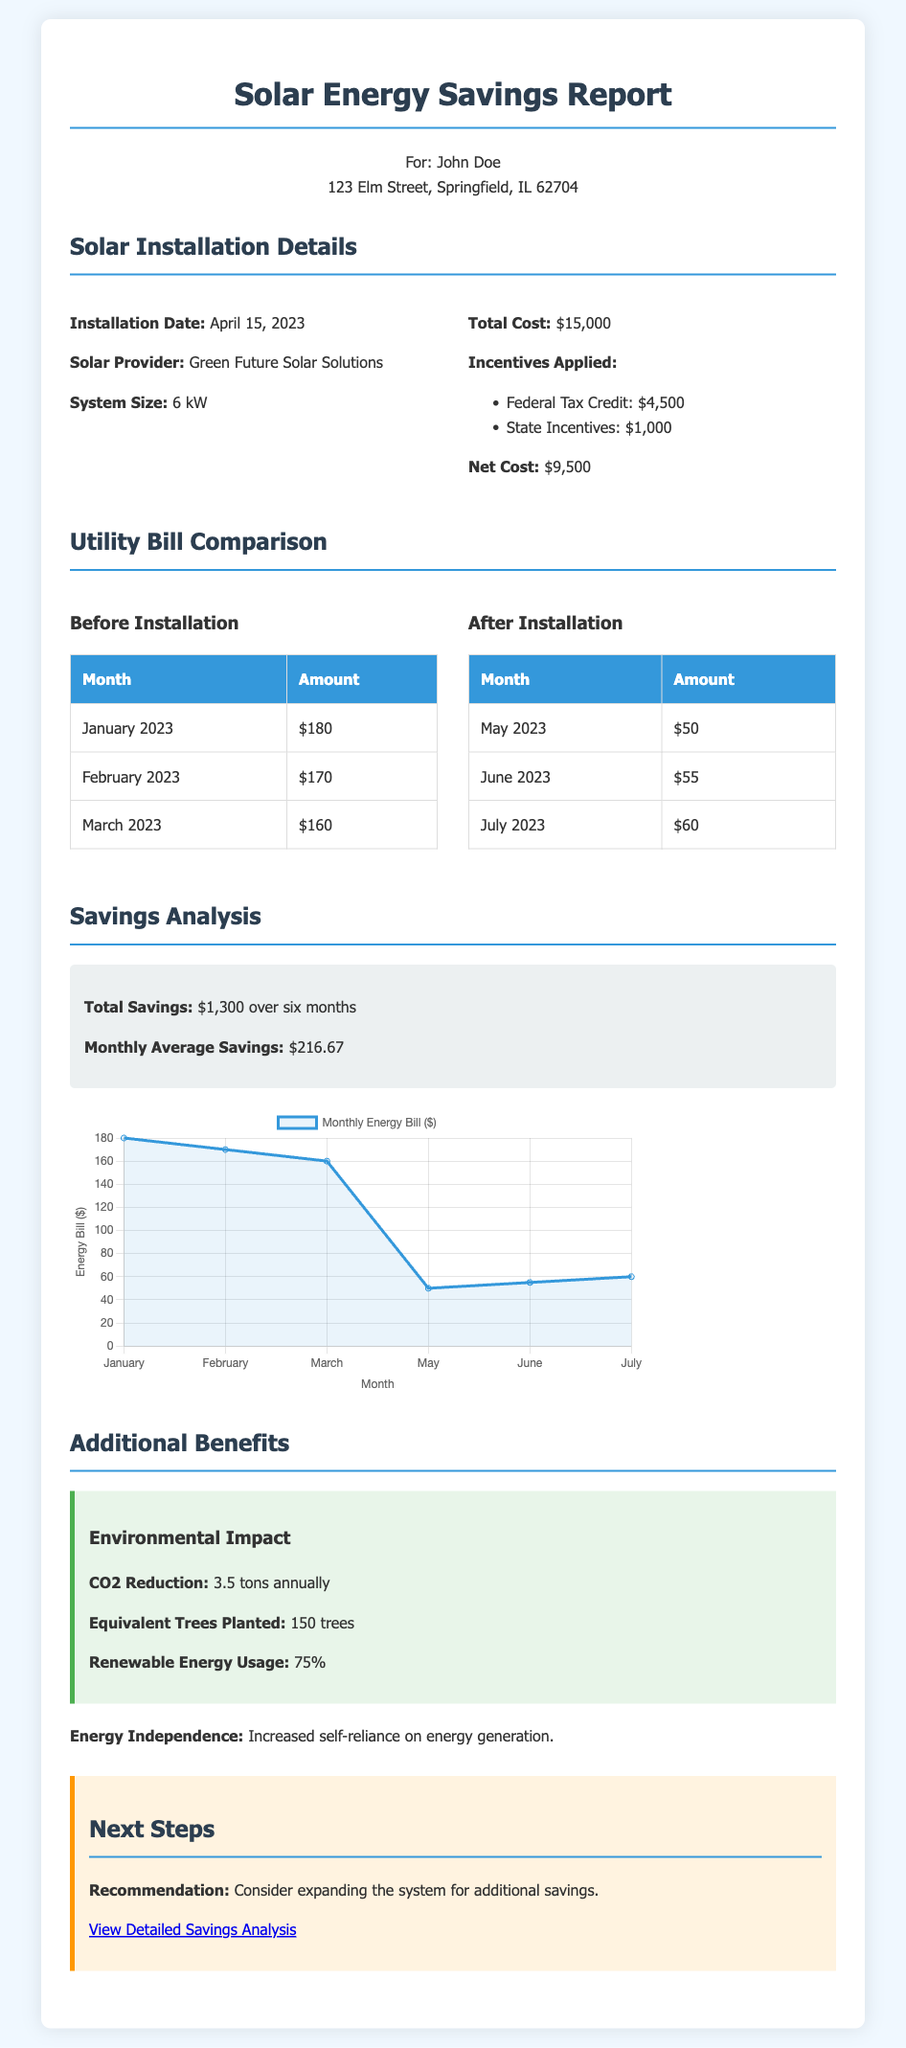what is the installation date? The installation date is stated in the section titled "Solar Installation Details."
Answer: April 15, 2023 what is the total cost of the solar installation? The total cost is mentioned in the Solar Installation Details section.
Answer: $15,000 how much was saved in total over six months? The total savings are specifically highlighted in the Savings Analysis section.
Answer: $1,300 what were the utility bills in January 2023? The bill amount for January 2023 is listed in the Utility Bill Comparison section.
Answer: $180 what is the monthly average savings? The monthly average savings are calculated and mentioned in the Savings Analysis section.
Answer: $216.67 how much CO2 reduction is achieved annually? The CO2 reduction is provided in the Additional Benefits section under Environmental Impact.
Answer: 3.5 tons which solar provider was used? The solar provider is mentioned in the Solar Installation Details section.
Answer: Green Future Solar Solutions what is the system size of the solar installation? The system size is detailed in the Solar Installation Details section.
Answer: 6 kW what was the utility bill amount for June 2023? The bill amount for June 2023 is included in the Utility Bill Comparison section.
Answer: $55 